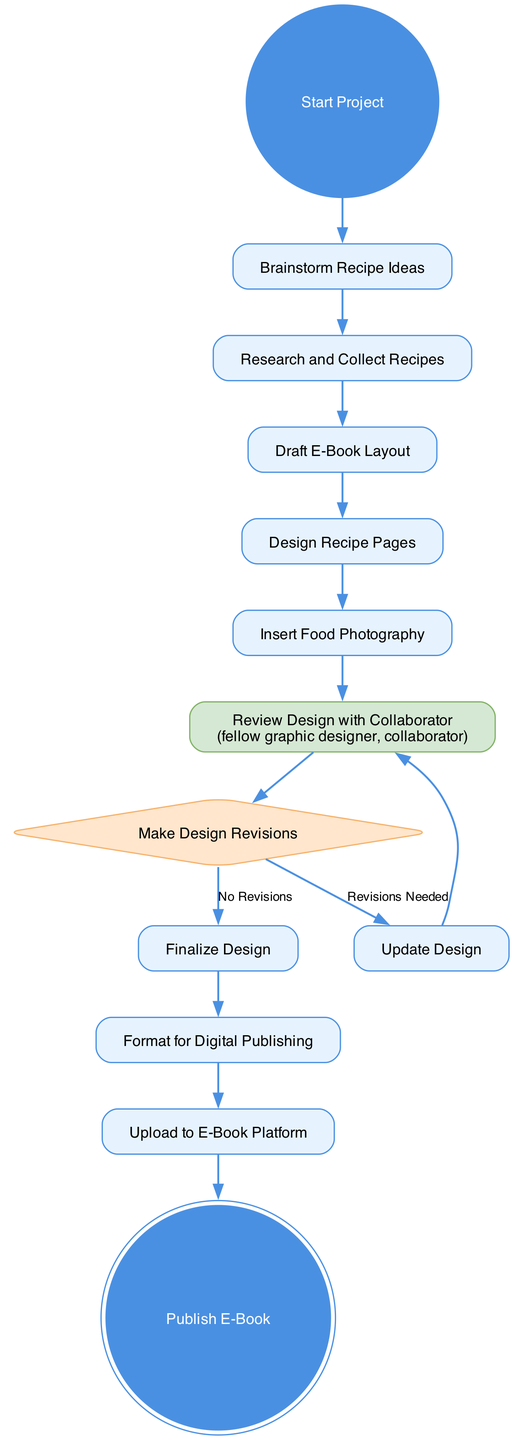What's the first activity in the diagram? The first activity is labeled as "Start Project," which is indicated as the initial node in the diagram.
Answer: Start Project How many main activities are there in the diagram? There are eleven main activities listed, including both actions and decisions as per the diagram data.
Answer: eleven What happens after "Review Design with Collaborator"? After "Review Design with Collaborator," the flow moves to "Make Design Revisions," which can lead to two different paths based on the revisions needed.
Answer: Make Design Revisions If revisions are needed, what is the next step? If revisions are needed, the next step is "Update Design," as indicated in the decision node leading from "Make Design Revisions."
Answer: Update Design What type of node is "Make Design Revisions"? "Make Design Revisions" is represented as a decision node, indicated by its diamond shape in the diagram.
Answer: decision What is the final activity of the diagram? The final activity is "Publish E-Book," which is shown as a double circle indicating its status as the end of the process.
Answer: Publish E-Book Which activities involve collaboration with another person? The activities "Review Design with Collaborator" specifically mention collaboration, indicating it involves another person in the review process.
Answer: Review Design with Collaborator How many possible outcomes are there from the "Make Design Revisions" decision? There are two possible outcomes from the "Make Design Revisions" decision: "Revisions Needed" and "No Revisions."
Answer: two What activity comes immediately before "Upload to E-Book Platform"? The activity that comes immediately before "Upload to E-Book Platform" is "Format for Digital Publishing," which is connected directly in the flow.
Answer: Format for Digital Publishing 